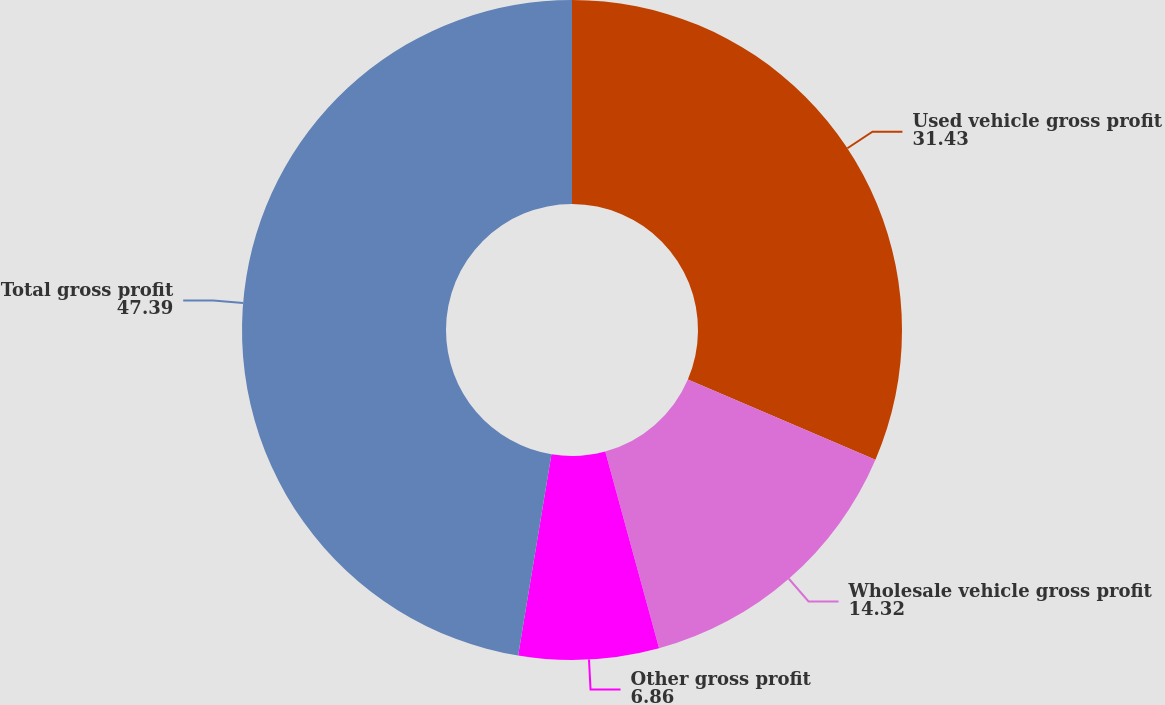Convert chart. <chart><loc_0><loc_0><loc_500><loc_500><pie_chart><fcel>Used vehicle gross profit<fcel>Wholesale vehicle gross profit<fcel>Other gross profit<fcel>Total gross profit<nl><fcel>31.43%<fcel>14.32%<fcel>6.86%<fcel>47.39%<nl></chart> 